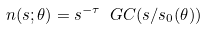Convert formula to latex. <formula><loc_0><loc_0><loc_500><loc_500>n ( s ; \theta ) = s ^ { - \tau } \ G C ( s / s _ { 0 } ( \theta ) )</formula> 